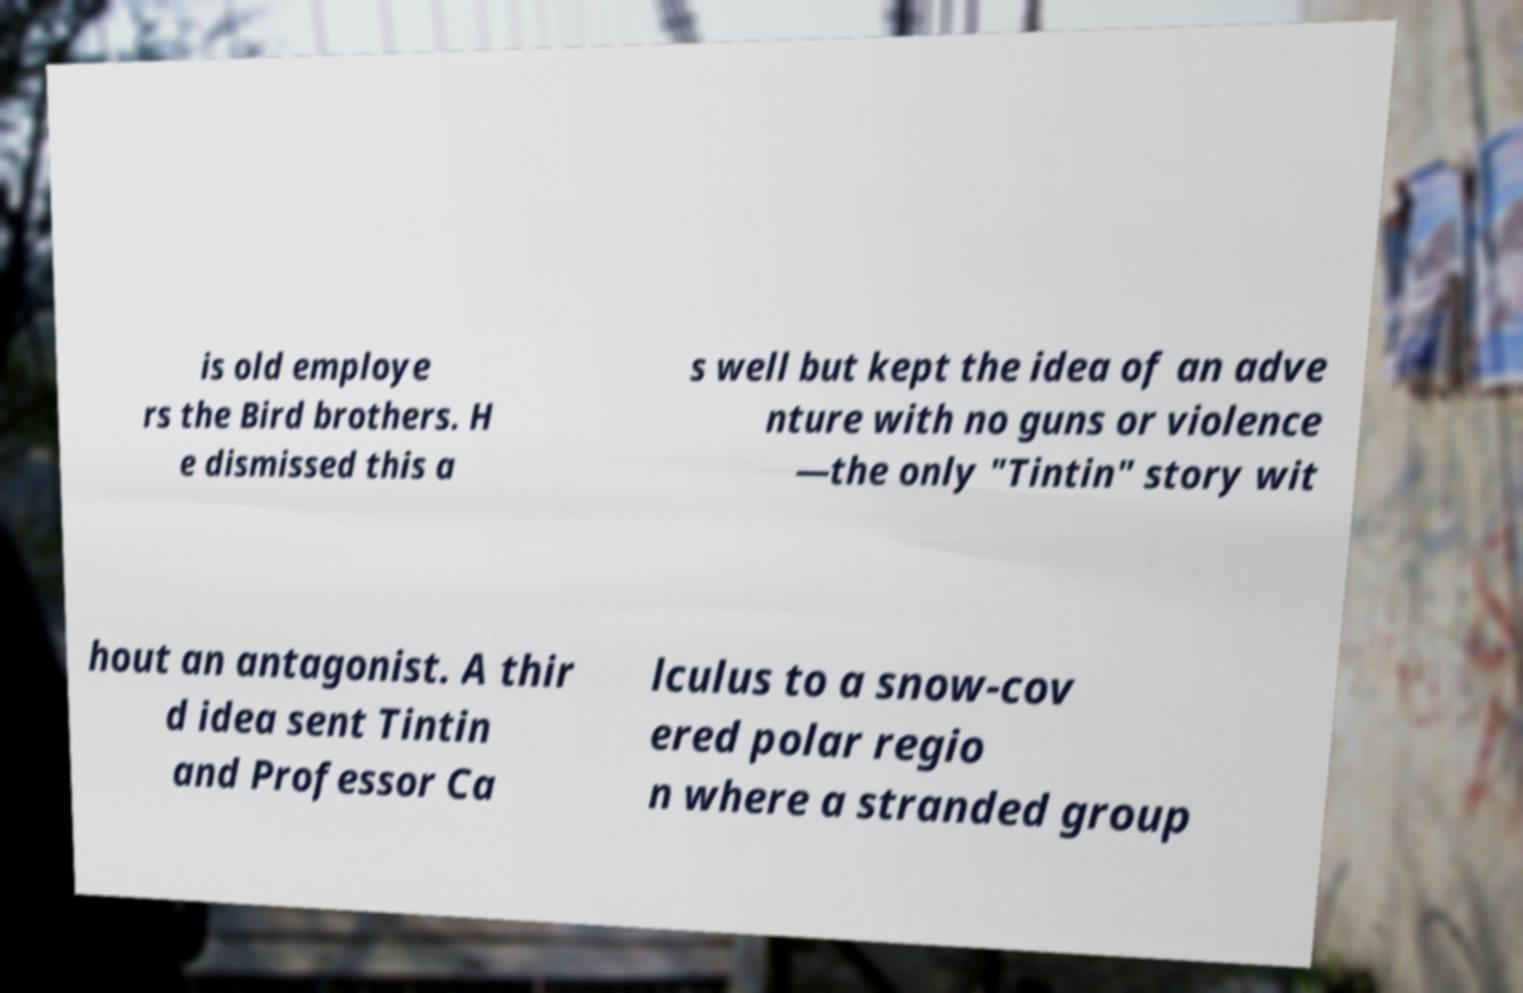There's text embedded in this image that I need extracted. Can you transcribe it verbatim? is old employe rs the Bird brothers. H e dismissed this a s well but kept the idea of an adve nture with no guns or violence —the only "Tintin" story wit hout an antagonist. A thir d idea sent Tintin and Professor Ca lculus to a snow-cov ered polar regio n where a stranded group 